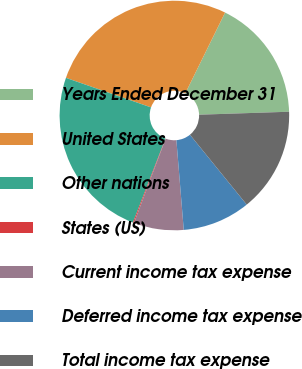<chart> <loc_0><loc_0><loc_500><loc_500><pie_chart><fcel>Years Ended December 31<fcel>United States<fcel>Other nations<fcel>States (US)<fcel>Current income tax expense<fcel>Deferred income tax expense<fcel>Total income tax expense<nl><fcel>17.19%<fcel>26.96%<fcel>24.44%<fcel>0.15%<fcel>7.03%<fcel>9.55%<fcel>14.67%<nl></chart> 